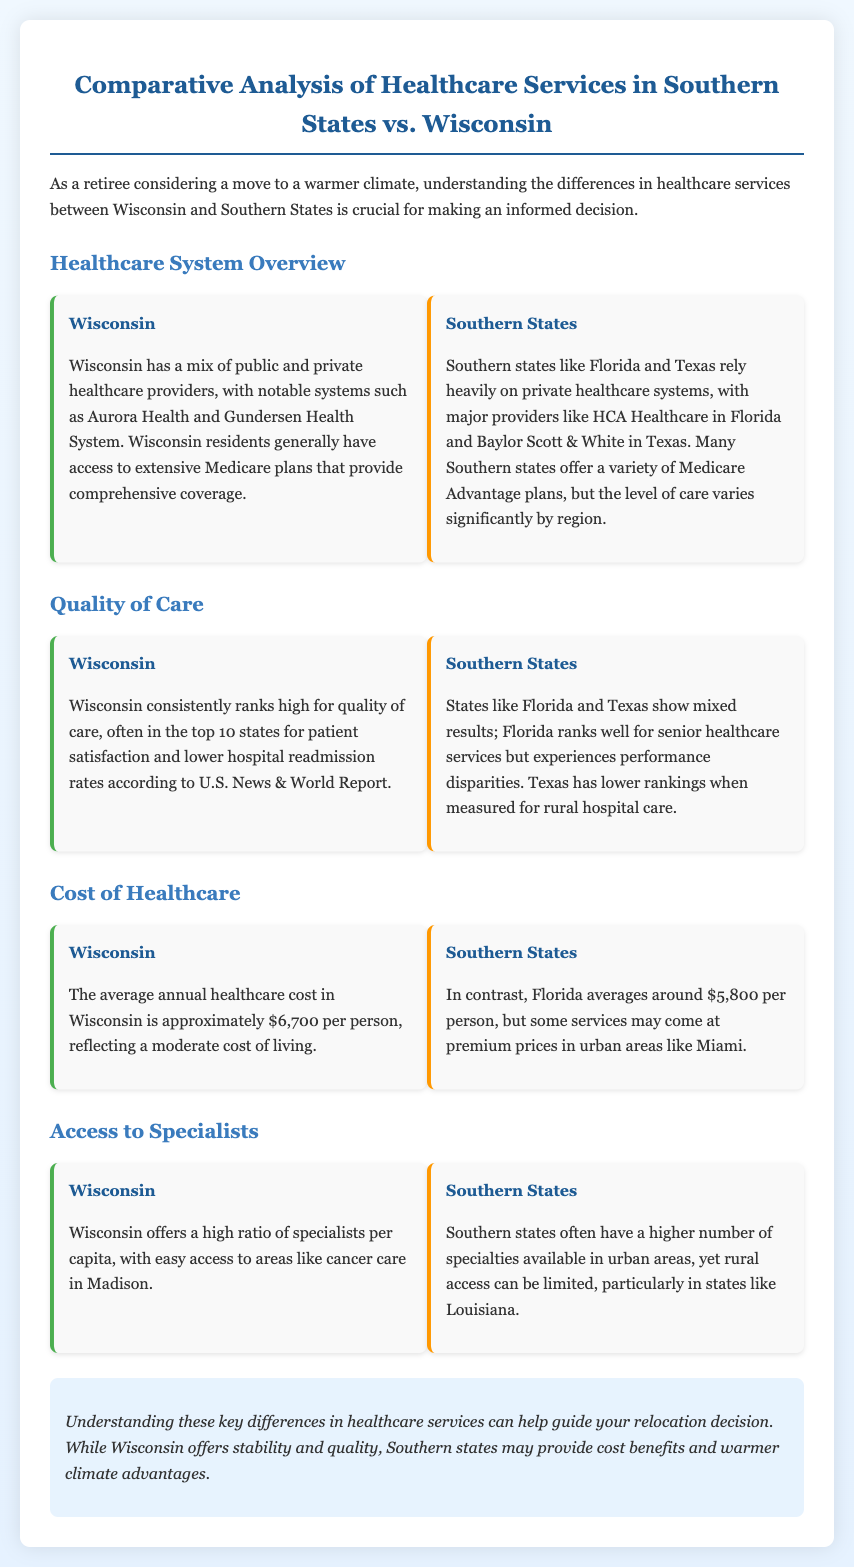What are the major healthcare systems in Wisconsin? Wisconsin has notable healthcare systems such as Aurora Health and Gundersen Health System.
Answer: Aurora Health and Gundersen Health System What is the average annual healthcare cost in Florida? The document states that the average annual healthcare cost in Florida is around $5,800 per person.
Answer: $5,800 Which state ranks high for patient satisfaction? According to the document, Wisconsin consistently ranks high for quality of care and patient satisfaction.
Answer: Wisconsin How does access to specialists in Wisconsin compare to Southern states? Wisconsin offers a high ratio of specialists per capita with easy access to areas like cancer care, while Southern states have limited rural access.
Answer: High access in Wisconsin; limited in Southern states What is a notable issue in Texas regarding healthcare? Texas has lower rankings when measured for rural hospital care.
Answer: Lower rankings for rural hospital care Which state is mentioned as having premium healthcare service prices in urban areas? The document mentions that some services in urban areas of Florida may come at premium prices.
Answer: Florida What is the document's conclusion about healthcare services? The conclusion mentions that Wisconsin offers stability and quality, while Southern states may provide cost benefits and warmer climate advantages.
Answer: Stability and quality in Wisconsin; cost benefits in Southern states What does Wisconsin's healthcare provider mix consist of? Wisconsin has a mix of public and private healthcare providers.
Answer: Public and private providers Which metric shows Florida's mixed results in healthcare? Florida shows mixed results in healthcare, especially with performance disparities in senior healthcare services.
Answer: Performance disparities in senior healthcare services 